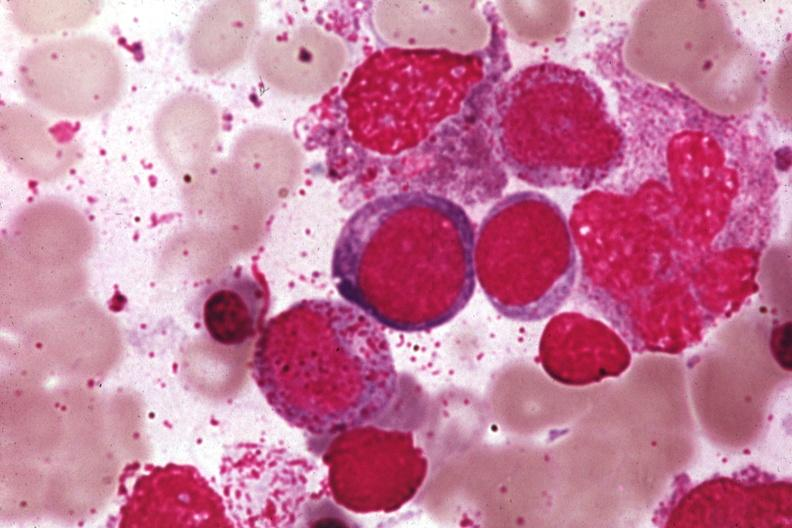s megaloblasts pernicious anemia present?
Answer the question using a single word or phrase. Yes 